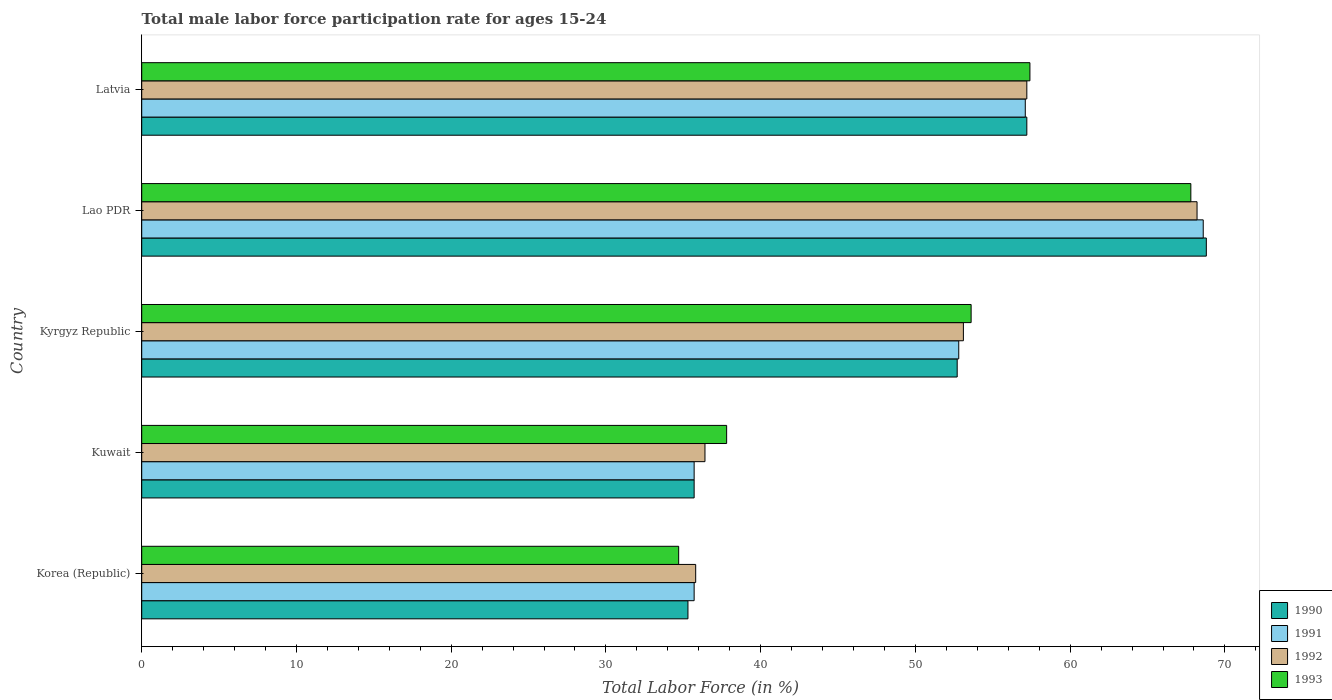How many groups of bars are there?
Keep it short and to the point. 5. Are the number of bars per tick equal to the number of legend labels?
Ensure brevity in your answer.  Yes. Are the number of bars on each tick of the Y-axis equal?
Provide a succinct answer. Yes. How many bars are there on the 1st tick from the top?
Keep it short and to the point. 4. What is the label of the 1st group of bars from the top?
Your answer should be very brief. Latvia. In how many cases, is the number of bars for a given country not equal to the number of legend labels?
Your answer should be compact. 0. What is the male labor force participation rate in 1992 in Latvia?
Make the answer very short. 57.2. Across all countries, what is the maximum male labor force participation rate in 1990?
Your answer should be compact. 68.8. Across all countries, what is the minimum male labor force participation rate in 1990?
Keep it short and to the point. 35.3. In which country was the male labor force participation rate in 1993 maximum?
Offer a very short reply. Lao PDR. In which country was the male labor force participation rate in 1991 minimum?
Ensure brevity in your answer.  Korea (Republic). What is the total male labor force participation rate in 1993 in the graph?
Keep it short and to the point. 251.3. What is the difference between the male labor force participation rate in 1991 in Korea (Republic) and that in Latvia?
Ensure brevity in your answer.  -21.4. What is the difference between the male labor force participation rate in 1991 in Korea (Republic) and the male labor force participation rate in 1990 in Latvia?
Your answer should be compact. -21.5. What is the average male labor force participation rate in 1993 per country?
Your answer should be compact. 50.26. What is the difference between the male labor force participation rate in 1991 and male labor force participation rate in 1992 in Lao PDR?
Keep it short and to the point. 0.4. What is the ratio of the male labor force participation rate in 1990 in Lao PDR to that in Latvia?
Ensure brevity in your answer.  1.2. What is the difference between the highest and the second highest male labor force participation rate in 1993?
Offer a terse response. 10.4. What is the difference between the highest and the lowest male labor force participation rate in 1993?
Provide a short and direct response. 33.1. Is the sum of the male labor force participation rate in 1991 in Kyrgyz Republic and Lao PDR greater than the maximum male labor force participation rate in 1990 across all countries?
Your answer should be very brief. Yes. Is it the case that in every country, the sum of the male labor force participation rate in 1992 and male labor force participation rate in 1993 is greater than the sum of male labor force participation rate in 1991 and male labor force participation rate in 1990?
Your answer should be very brief. No. What does the 2nd bar from the top in Korea (Republic) represents?
Ensure brevity in your answer.  1992. Are the values on the major ticks of X-axis written in scientific E-notation?
Your answer should be very brief. No. Where does the legend appear in the graph?
Your response must be concise. Bottom right. How many legend labels are there?
Provide a succinct answer. 4. How are the legend labels stacked?
Provide a short and direct response. Vertical. What is the title of the graph?
Provide a succinct answer. Total male labor force participation rate for ages 15-24. Does "1961" appear as one of the legend labels in the graph?
Keep it short and to the point. No. What is the label or title of the Y-axis?
Offer a very short reply. Country. What is the Total Labor Force (in %) in 1990 in Korea (Republic)?
Offer a very short reply. 35.3. What is the Total Labor Force (in %) of 1991 in Korea (Republic)?
Your answer should be compact. 35.7. What is the Total Labor Force (in %) of 1992 in Korea (Republic)?
Offer a terse response. 35.8. What is the Total Labor Force (in %) in 1993 in Korea (Republic)?
Keep it short and to the point. 34.7. What is the Total Labor Force (in %) of 1990 in Kuwait?
Your response must be concise. 35.7. What is the Total Labor Force (in %) of 1991 in Kuwait?
Make the answer very short. 35.7. What is the Total Labor Force (in %) of 1992 in Kuwait?
Your response must be concise. 36.4. What is the Total Labor Force (in %) of 1993 in Kuwait?
Provide a short and direct response. 37.8. What is the Total Labor Force (in %) of 1990 in Kyrgyz Republic?
Give a very brief answer. 52.7. What is the Total Labor Force (in %) of 1991 in Kyrgyz Republic?
Give a very brief answer. 52.8. What is the Total Labor Force (in %) in 1992 in Kyrgyz Republic?
Offer a very short reply. 53.1. What is the Total Labor Force (in %) of 1993 in Kyrgyz Republic?
Keep it short and to the point. 53.6. What is the Total Labor Force (in %) of 1990 in Lao PDR?
Provide a short and direct response. 68.8. What is the Total Labor Force (in %) of 1991 in Lao PDR?
Offer a terse response. 68.6. What is the Total Labor Force (in %) of 1992 in Lao PDR?
Make the answer very short. 68.2. What is the Total Labor Force (in %) in 1993 in Lao PDR?
Offer a very short reply. 67.8. What is the Total Labor Force (in %) of 1990 in Latvia?
Make the answer very short. 57.2. What is the Total Labor Force (in %) in 1991 in Latvia?
Offer a very short reply. 57.1. What is the Total Labor Force (in %) in 1992 in Latvia?
Your answer should be very brief. 57.2. What is the Total Labor Force (in %) of 1993 in Latvia?
Offer a terse response. 57.4. Across all countries, what is the maximum Total Labor Force (in %) of 1990?
Provide a succinct answer. 68.8. Across all countries, what is the maximum Total Labor Force (in %) in 1991?
Keep it short and to the point. 68.6. Across all countries, what is the maximum Total Labor Force (in %) of 1992?
Offer a terse response. 68.2. Across all countries, what is the maximum Total Labor Force (in %) of 1993?
Offer a very short reply. 67.8. Across all countries, what is the minimum Total Labor Force (in %) of 1990?
Your answer should be compact. 35.3. Across all countries, what is the minimum Total Labor Force (in %) in 1991?
Keep it short and to the point. 35.7. Across all countries, what is the minimum Total Labor Force (in %) in 1992?
Your answer should be compact. 35.8. Across all countries, what is the minimum Total Labor Force (in %) in 1993?
Offer a terse response. 34.7. What is the total Total Labor Force (in %) in 1990 in the graph?
Give a very brief answer. 249.7. What is the total Total Labor Force (in %) in 1991 in the graph?
Your answer should be compact. 249.9. What is the total Total Labor Force (in %) in 1992 in the graph?
Keep it short and to the point. 250.7. What is the total Total Labor Force (in %) of 1993 in the graph?
Offer a very short reply. 251.3. What is the difference between the Total Labor Force (in %) of 1992 in Korea (Republic) and that in Kuwait?
Provide a short and direct response. -0.6. What is the difference between the Total Labor Force (in %) in 1993 in Korea (Republic) and that in Kuwait?
Provide a short and direct response. -3.1. What is the difference between the Total Labor Force (in %) in 1990 in Korea (Republic) and that in Kyrgyz Republic?
Offer a very short reply. -17.4. What is the difference between the Total Labor Force (in %) of 1991 in Korea (Republic) and that in Kyrgyz Republic?
Offer a very short reply. -17.1. What is the difference between the Total Labor Force (in %) in 1992 in Korea (Republic) and that in Kyrgyz Republic?
Give a very brief answer. -17.3. What is the difference between the Total Labor Force (in %) in 1993 in Korea (Republic) and that in Kyrgyz Republic?
Keep it short and to the point. -18.9. What is the difference between the Total Labor Force (in %) of 1990 in Korea (Republic) and that in Lao PDR?
Make the answer very short. -33.5. What is the difference between the Total Labor Force (in %) in 1991 in Korea (Republic) and that in Lao PDR?
Offer a very short reply. -32.9. What is the difference between the Total Labor Force (in %) in 1992 in Korea (Republic) and that in Lao PDR?
Ensure brevity in your answer.  -32.4. What is the difference between the Total Labor Force (in %) in 1993 in Korea (Republic) and that in Lao PDR?
Keep it short and to the point. -33.1. What is the difference between the Total Labor Force (in %) of 1990 in Korea (Republic) and that in Latvia?
Provide a succinct answer. -21.9. What is the difference between the Total Labor Force (in %) in 1991 in Korea (Republic) and that in Latvia?
Offer a terse response. -21.4. What is the difference between the Total Labor Force (in %) of 1992 in Korea (Republic) and that in Latvia?
Your answer should be very brief. -21.4. What is the difference between the Total Labor Force (in %) in 1993 in Korea (Republic) and that in Latvia?
Provide a short and direct response. -22.7. What is the difference between the Total Labor Force (in %) in 1991 in Kuwait and that in Kyrgyz Republic?
Give a very brief answer. -17.1. What is the difference between the Total Labor Force (in %) in 1992 in Kuwait and that in Kyrgyz Republic?
Your answer should be very brief. -16.7. What is the difference between the Total Labor Force (in %) in 1993 in Kuwait and that in Kyrgyz Republic?
Your response must be concise. -15.8. What is the difference between the Total Labor Force (in %) of 1990 in Kuwait and that in Lao PDR?
Your response must be concise. -33.1. What is the difference between the Total Labor Force (in %) of 1991 in Kuwait and that in Lao PDR?
Offer a terse response. -32.9. What is the difference between the Total Labor Force (in %) of 1992 in Kuwait and that in Lao PDR?
Provide a succinct answer. -31.8. What is the difference between the Total Labor Force (in %) of 1990 in Kuwait and that in Latvia?
Offer a very short reply. -21.5. What is the difference between the Total Labor Force (in %) of 1991 in Kuwait and that in Latvia?
Make the answer very short. -21.4. What is the difference between the Total Labor Force (in %) in 1992 in Kuwait and that in Latvia?
Provide a succinct answer. -20.8. What is the difference between the Total Labor Force (in %) in 1993 in Kuwait and that in Latvia?
Provide a short and direct response. -19.6. What is the difference between the Total Labor Force (in %) in 1990 in Kyrgyz Republic and that in Lao PDR?
Offer a very short reply. -16.1. What is the difference between the Total Labor Force (in %) in 1991 in Kyrgyz Republic and that in Lao PDR?
Your answer should be compact. -15.8. What is the difference between the Total Labor Force (in %) in 1992 in Kyrgyz Republic and that in Lao PDR?
Your answer should be very brief. -15.1. What is the difference between the Total Labor Force (in %) of 1992 in Kyrgyz Republic and that in Latvia?
Your answer should be compact. -4.1. What is the difference between the Total Labor Force (in %) in 1993 in Kyrgyz Republic and that in Latvia?
Your answer should be compact. -3.8. What is the difference between the Total Labor Force (in %) of 1990 in Lao PDR and that in Latvia?
Keep it short and to the point. 11.6. What is the difference between the Total Labor Force (in %) of 1992 in Lao PDR and that in Latvia?
Your response must be concise. 11. What is the difference between the Total Labor Force (in %) of 1990 in Korea (Republic) and the Total Labor Force (in %) of 1991 in Kuwait?
Keep it short and to the point. -0.4. What is the difference between the Total Labor Force (in %) of 1990 in Korea (Republic) and the Total Labor Force (in %) of 1993 in Kuwait?
Your response must be concise. -2.5. What is the difference between the Total Labor Force (in %) in 1991 in Korea (Republic) and the Total Labor Force (in %) in 1992 in Kuwait?
Provide a succinct answer. -0.7. What is the difference between the Total Labor Force (in %) in 1991 in Korea (Republic) and the Total Labor Force (in %) in 1993 in Kuwait?
Provide a short and direct response. -2.1. What is the difference between the Total Labor Force (in %) of 1992 in Korea (Republic) and the Total Labor Force (in %) of 1993 in Kuwait?
Offer a very short reply. -2. What is the difference between the Total Labor Force (in %) of 1990 in Korea (Republic) and the Total Labor Force (in %) of 1991 in Kyrgyz Republic?
Provide a succinct answer. -17.5. What is the difference between the Total Labor Force (in %) in 1990 in Korea (Republic) and the Total Labor Force (in %) in 1992 in Kyrgyz Republic?
Ensure brevity in your answer.  -17.8. What is the difference between the Total Labor Force (in %) in 1990 in Korea (Republic) and the Total Labor Force (in %) in 1993 in Kyrgyz Republic?
Offer a terse response. -18.3. What is the difference between the Total Labor Force (in %) of 1991 in Korea (Republic) and the Total Labor Force (in %) of 1992 in Kyrgyz Republic?
Provide a short and direct response. -17.4. What is the difference between the Total Labor Force (in %) in 1991 in Korea (Republic) and the Total Labor Force (in %) in 1993 in Kyrgyz Republic?
Make the answer very short. -17.9. What is the difference between the Total Labor Force (in %) of 1992 in Korea (Republic) and the Total Labor Force (in %) of 1993 in Kyrgyz Republic?
Provide a short and direct response. -17.8. What is the difference between the Total Labor Force (in %) in 1990 in Korea (Republic) and the Total Labor Force (in %) in 1991 in Lao PDR?
Offer a terse response. -33.3. What is the difference between the Total Labor Force (in %) of 1990 in Korea (Republic) and the Total Labor Force (in %) of 1992 in Lao PDR?
Offer a terse response. -32.9. What is the difference between the Total Labor Force (in %) of 1990 in Korea (Republic) and the Total Labor Force (in %) of 1993 in Lao PDR?
Your answer should be very brief. -32.5. What is the difference between the Total Labor Force (in %) of 1991 in Korea (Republic) and the Total Labor Force (in %) of 1992 in Lao PDR?
Give a very brief answer. -32.5. What is the difference between the Total Labor Force (in %) of 1991 in Korea (Republic) and the Total Labor Force (in %) of 1993 in Lao PDR?
Your answer should be compact. -32.1. What is the difference between the Total Labor Force (in %) of 1992 in Korea (Republic) and the Total Labor Force (in %) of 1993 in Lao PDR?
Make the answer very short. -32. What is the difference between the Total Labor Force (in %) of 1990 in Korea (Republic) and the Total Labor Force (in %) of 1991 in Latvia?
Offer a terse response. -21.8. What is the difference between the Total Labor Force (in %) of 1990 in Korea (Republic) and the Total Labor Force (in %) of 1992 in Latvia?
Your response must be concise. -21.9. What is the difference between the Total Labor Force (in %) in 1990 in Korea (Republic) and the Total Labor Force (in %) in 1993 in Latvia?
Ensure brevity in your answer.  -22.1. What is the difference between the Total Labor Force (in %) in 1991 in Korea (Republic) and the Total Labor Force (in %) in 1992 in Latvia?
Provide a short and direct response. -21.5. What is the difference between the Total Labor Force (in %) in 1991 in Korea (Republic) and the Total Labor Force (in %) in 1993 in Latvia?
Offer a very short reply. -21.7. What is the difference between the Total Labor Force (in %) of 1992 in Korea (Republic) and the Total Labor Force (in %) of 1993 in Latvia?
Your answer should be compact. -21.6. What is the difference between the Total Labor Force (in %) in 1990 in Kuwait and the Total Labor Force (in %) in 1991 in Kyrgyz Republic?
Your answer should be compact. -17.1. What is the difference between the Total Labor Force (in %) in 1990 in Kuwait and the Total Labor Force (in %) in 1992 in Kyrgyz Republic?
Offer a very short reply. -17.4. What is the difference between the Total Labor Force (in %) in 1990 in Kuwait and the Total Labor Force (in %) in 1993 in Kyrgyz Republic?
Keep it short and to the point. -17.9. What is the difference between the Total Labor Force (in %) of 1991 in Kuwait and the Total Labor Force (in %) of 1992 in Kyrgyz Republic?
Offer a very short reply. -17.4. What is the difference between the Total Labor Force (in %) of 1991 in Kuwait and the Total Labor Force (in %) of 1993 in Kyrgyz Republic?
Your answer should be very brief. -17.9. What is the difference between the Total Labor Force (in %) of 1992 in Kuwait and the Total Labor Force (in %) of 1993 in Kyrgyz Republic?
Offer a terse response. -17.2. What is the difference between the Total Labor Force (in %) in 1990 in Kuwait and the Total Labor Force (in %) in 1991 in Lao PDR?
Make the answer very short. -32.9. What is the difference between the Total Labor Force (in %) in 1990 in Kuwait and the Total Labor Force (in %) in 1992 in Lao PDR?
Offer a terse response. -32.5. What is the difference between the Total Labor Force (in %) in 1990 in Kuwait and the Total Labor Force (in %) in 1993 in Lao PDR?
Give a very brief answer. -32.1. What is the difference between the Total Labor Force (in %) of 1991 in Kuwait and the Total Labor Force (in %) of 1992 in Lao PDR?
Your answer should be very brief. -32.5. What is the difference between the Total Labor Force (in %) in 1991 in Kuwait and the Total Labor Force (in %) in 1993 in Lao PDR?
Provide a short and direct response. -32.1. What is the difference between the Total Labor Force (in %) of 1992 in Kuwait and the Total Labor Force (in %) of 1993 in Lao PDR?
Your answer should be very brief. -31.4. What is the difference between the Total Labor Force (in %) in 1990 in Kuwait and the Total Labor Force (in %) in 1991 in Latvia?
Provide a succinct answer. -21.4. What is the difference between the Total Labor Force (in %) in 1990 in Kuwait and the Total Labor Force (in %) in 1992 in Latvia?
Offer a terse response. -21.5. What is the difference between the Total Labor Force (in %) of 1990 in Kuwait and the Total Labor Force (in %) of 1993 in Latvia?
Your answer should be very brief. -21.7. What is the difference between the Total Labor Force (in %) in 1991 in Kuwait and the Total Labor Force (in %) in 1992 in Latvia?
Make the answer very short. -21.5. What is the difference between the Total Labor Force (in %) of 1991 in Kuwait and the Total Labor Force (in %) of 1993 in Latvia?
Offer a terse response. -21.7. What is the difference between the Total Labor Force (in %) of 1990 in Kyrgyz Republic and the Total Labor Force (in %) of 1991 in Lao PDR?
Your answer should be very brief. -15.9. What is the difference between the Total Labor Force (in %) of 1990 in Kyrgyz Republic and the Total Labor Force (in %) of 1992 in Lao PDR?
Provide a short and direct response. -15.5. What is the difference between the Total Labor Force (in %) of 1990 in Kyrgyz Republic and the Total Labor Force (in %) of 1993 in Lao PDR?
Make the answer very short. -15.1. What is the difference between the Total Labor Force (in %) of 1991 in Kyrgyz Republic and the Total Labor Force (in %) of 1992 in Lao PDR?
Ensure brevity in your answer.  -15.4. What is the difference between the Total Labor Force (in %) in 1992 in Kyrgyz Republic and the Total Labor Force (in %) in 1993 in Lao PDR?
Your answer should be compact. -14.7. What is the difference between the Total Labor Force (in %) of 1990 in Kyrgyz Republic and the Total Labor Force (in %) of 1992 in Latvia?
Your response must be concise. -4.5. What is the difference between the Total Labor Force (in %) of 1990 in Kyrgyz Republic and the Total Labor Force (in %) of 1993 in Latvia?
Provide a short and direct response. -4.7. What is the difference between the Total Labor Force (in %) in 1991 in Lao PDR and the Total Labor Force (in %) in 1992 in Latvia?
Offer a terse response. 11.4. What is the difference between the Total Labor Force (in %) of 1991 in Lao PDR and the Total Labor Force (in %) of 1993 in Latvia?
Keep it short and to the point. 11.2. What is the average Total Labor Force (in %) of 1990 per country?
Provide a short and direct response. 49.94. What is the average Total Labor Force (in %) in 1991 per country?
Ensure brevity in your answer.  49.98. What is the average Total Labor Force (in %) of 1992 per country?
Offer a very short reply. 50.14. What is the average Total Labor Force (in %) of 1993 per country?
Your answer should be compact. 50.26. What is the difference between the Total Labor Force (in %) in 1991 and Total Labor Force (in %) in 1993 in Korea (Republic)?
Your answer should be compact. 1. What is the difference between the Total Labor Force (in %) of 1990 and Total Labor Force (in %) of 1992 in Kuwait?
Offer a very short reply. -0.7. What is the difference between the Total Labor Force (in %) in 1990 and Total Labor Force (in %) in 1993 in Kuwait?
Make the answer very short. -2.1. What is the difference between the Total Labor Force (in %) of 1991 and Total Labor Force (in %) of 1992 in Kuwait?
Keep it short and to the point. -0.7. What is the difference between the Total Labor Force (in %) of 1990 and Total Labor Force (in %) of 1991 in Kyrgyz Republic?
Your response must be concise. -0.1. What is the difference between the Total Labor Force (in %) in 1991 and Total Labor Force (in %) in 1992 in Kyrgyz Republic?
Ensure brevity in your answer.  -0.3. What is the difference between the Total Labor Force (in %) in 1990 and Total Labor Force (in %) in 1992 in Lao PDR?
Keep it short and to the point. 0.6. What is the difference between the Total Labor Force (in %) of 1990 and Total Labor Force (in %) of 1993 in Lao PDR?
Your answer should be very brief. 1. What is the difference between the Total Labor Force (in %) in 1991 and Total Labor Force (in %) in 1992 in Lao PDR?
Give a very brief answer. 0.4. What is the difference between the Total Labor Force (in %) in 1992 and Total Labor Force (in %) in 1993 in Lao PDR?
Make the answer very short. 0.4. What is the difference between the Total Labor Force (in %) in 1990 and Total Labor Force (in %) in 1991 in Latvia?
Ensure brevity in your answer.  0.1. What is the difference between the Total Labor Force (in %) in 1990 and Total Labor Force (in %) in 1992 in Latvia?
Your answer should be compact. 0. What is the difference between the Total Labor Force (in %) of 1990 and Total Labor Force (in %) of 1993 in Latvia?
Offer a very short reply. -0.2. What is the difference between the Total Labor Force (in %) of 1991 and Total Labor Force (in %) of 1992 in Latvia?
Offer a very short reply. -0.1. What is the difference between the Total Labor Force (in %) of 1992 and Total Labor Force (in %) of 1993 in Latvia?
Make the answer very short. -0.2. What is the ratio of the Total Labor Force (in %) of 1990 in Korea (Republic) to that in Kuwait?
Your response must be concise. 0.99. What is the ratio of the Total Labor Force (in %) in 1992 in Korea (Republic) to that in Kuwait?
Your answer should be very brief. 0.98. What is the ratio of the Total Labor Force (in %) of 1993 in Korea (Republic) to that in Kuwait?
Keep it short and to the point. 0.92. What is the ratio of the Total Labor Force (in %) in 1990 in Korea (Republic) to that in Kyrgyz Republic?
Offer a terse response. 0.67. What is the ratio of the Total Labor Force (in %) in 1991 in Korea (Republic) to that in Kyrgyz Republic?
Your answer should be compact. 0.68. What is the ratio of the Total Labor Force (in %) in 1992 in Korea (Republic) to that in Kyrgyz Republic?
Provide a succinct answer. 0.67. What is the ratio of the Total Labor Force (in %) in 1993 in Korea (Republic) to that in Kyrgyz Republic?
Provide a succinct answer. 0.65. What is the ratio of the Total Labor Force (in %) of 1990 in Korea (Republic) to that in Lao PDR?
Give a very brief answer. 0.51. What is the ratio of the Total Labor Force (in %) in 1991 in Korea (Republic) to that in Lao PDR?
Provide a short and direct response. 0.52. What is the ratio of the Total Labor Force (in %) of 1992 in Korea (Republic) to that in Lao PDR?
Keep it short and to the point. 0.52. What is the ratio of the Total Labor Force (in %) of 1993 in Korea (Republic) to that in Lao PDR?
Make the answer very short. 0.51. What is the ratio of the Total Labor Force (in %) in 1990 in Korea (Republic) to that in Latvia?
Make the answer very short. 0.62. What is the ratio of the Total Labor Force (in %) of 1991 in Korea (Republic) to that in Latvia?
Provide a short and direct response. 0.63. What is the ratio of the Total Labor Force (in %) in 1992 in Korea (Republic) to that in Latvia?
Give a very brief answer. 0.63. What is the ratio of the Total Labor Force (in %) of 1993 in Korea (Republic) to that in Latvia?
Your response must be concise. 0.6. What is the ratio of the Total Labor Force (in %) of 1990 in Kuwait to that in Kyrgyz Republic?
Your response must be concise. 0.68. What is the ratio of the Total Labor Force (in %) in 1991 in Kuwait to that in Kyrgyz Republic?
Offer a terse response. 0.68. What is the ratio of the Total Labor Force (in %) in 1992 in Kuwait to that in Kyrgyz Republic?
Provide a short and direct response. 0.69. What is the ratio of the Total Labor Force (in %) in 1993 in Kuwait to that in Kyrgyz Republic?
Your response must be concise. 0.71. What is the ratio of the Total Labor Force (in %) in 1990 in Kuwait to that in Lao PDR?
Your answer should be very brief. 0.52. What is the ratio of the Total Labor Force (in %) in 1991 in Kuwait to that in Lao PDR?
Keep it short and to the point. 0.52. What is the ratio of the Total Labor Force (in %) of 1992 in Kuwait to that in Lao PDR?
Keep it short and to the point. 0.53. What is the ratio of the Total Labor Force (in %) in 1993 in Kuwait to that in Lao PDR?
Ensure brevity in your answer.  0.56. What is the ratio of the Total Labor Force (in %) of 1990 in Kuwait to that in Latvia?
Offer a very short reply. 0.62. What is the ratio of the Total Labor Force (in %) in 1991 in Kuwait to that in Latvia?
Your answer should be compact. 0.63. What is the ratio of the Total Labor Force (in %) of 1992 in Kuwait to that in Latvia?
Your answer should be very brief. 0.64. What is the ratio of the Total Labor Force (in %) in 1993 in Kuwait to that in Latvia?
Provide a short and direct response. 0.66. What is the ratio of the Total Labor Force (in %) of 1990 in Kyrgyz Republic to that in Lao PDR?
Keep it short and to the point. 0.77. What is the ratio of the Total Labor Force (in %) in 1991 in Kyrgyz Republic to that in Lao PDR?
Your answer should be very brief. 0.77. What is the ratio of the Total Labor Force (in %) of 1992 in Kyrgyz Republic to that in Lao PDR?
Offer a very short reply. 0.78. What is the ratio of the Total Labor Force (in %) in 1993 in Kyrgyz Republic to that in Lao PDR?
Offer a very short reply. 0.79. What is the ratio of the Total Labor Force (in %) of 1990 in Kyrgyz Republic to that in Latvia?
Give a very brief answer. 0.92. What is the ratio of the Total Labor Force (in %) of 1991 in Kyrgyz Republic to that in Latvia?
Your answer should be very brief. 0.92. What is the ratio of the Total Labor Force (in %) of 1992 in Kyrgyz Republic to that in Latvia?
Offer a very short reply. 0.93. What is the ratio of the Total Labor Force (in %) in 1993 in Kyrgyz Republic to that in Latvia?
Provide a short and direct response. 0.93. What is the ratio of the Total Labor Force (in %) in 1990 in Lao PDR to that in Latvia?
Offer a terse response. 1.2. What is the ratio of the Total Labor Force (in %) in 1991 in Lao PDR to that in Latvia?
Keep it short and to the point. 1.2. What is the ratio of the Total Labor Force (in %) in 1992 in Lao PDR to that in Latvia?
Your answer should be very brief. 1.19. What is the ratio of the Total Labor Force (in %) in 1993 in Lao PDR to that in Latvia?
Provide a succinct answer. 1.18. What is the difference between the highest and the second highest Total Labor Force (in %) of 1990?
Ensure brevity in your answer.  11.6. What is the difference between the highest and the second highest Total Labor Force (in %) of 1991?
Your answer should be compact. 11.5. What is the difference between the highest and the second highest Total Labor Force (in %) of 1992?
Provide a succinct answer. 11. What is the difference between the highest and the lowest Total Labor Force (in %) in 1990?
Your response must be concise. 33.5. What is the difference between the highest and the lowest Total Labor Force (in %) in 1991?
Your answer should be compact. 32.9. What is the difference between the highest and the lowest Total Labor Force (in %) of 1992?
Keep it short and to the point. 32.4. What is the difference between the highest and the lowest Total Labor Force (in %) in 1993?
Keep it short and to the point. 33.1. 